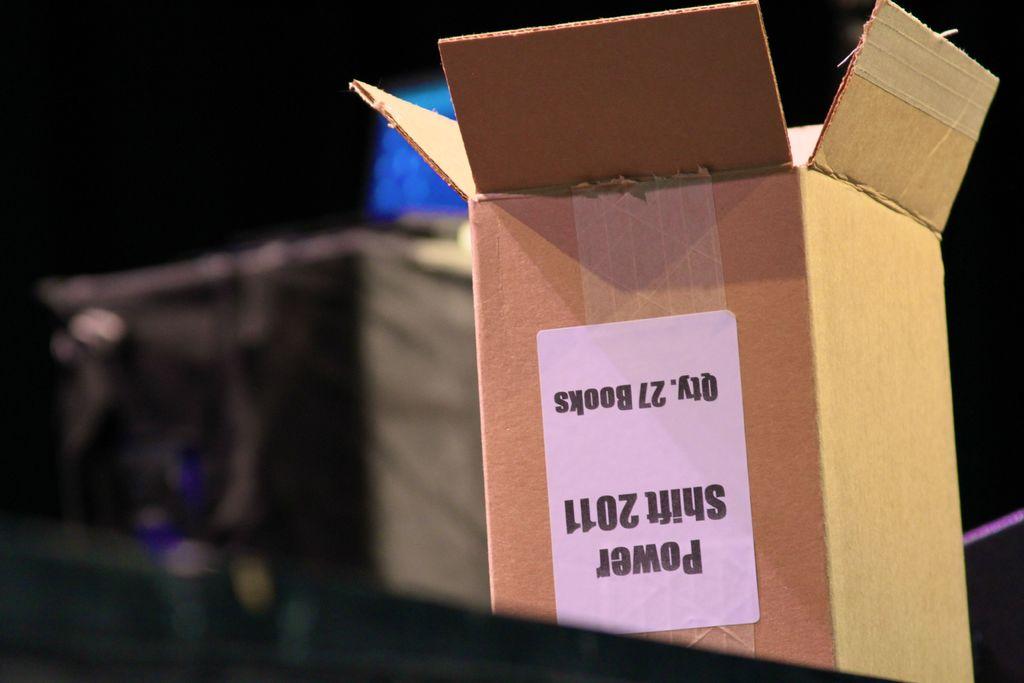Is this a car part?
Your response must be concise. Yes. How many books were in the box?
Your answer should be very brief. 27. 